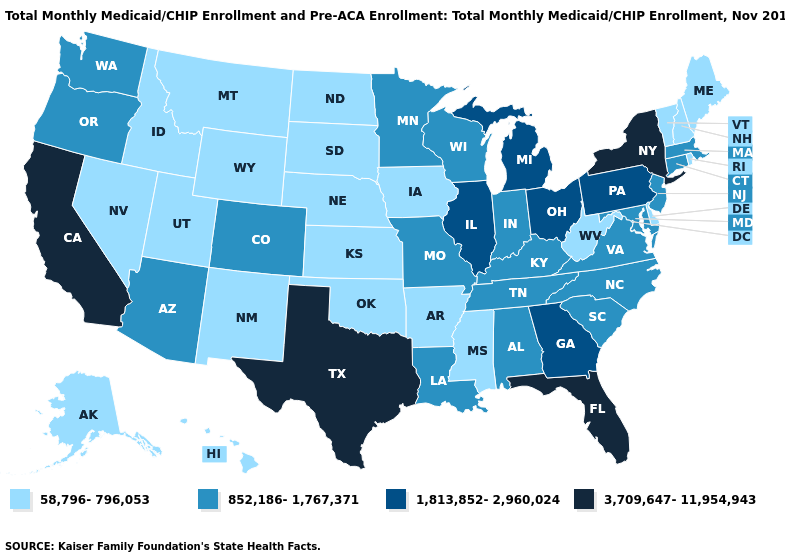How many symbols are there in the legend?
Concise answer only. 4. Is the legend a continuous bar?
Short answer required. No. What is the value of Connecticut?
Answer briefly. 852,186-1,767,371. Does Oregon have a higher value than New Hampshire?
Keep it brief. Yes. What is the value of Indiana?
Short answer required. 852,186-1,767,371. Name the states that have a value in the range 58,796-796,053?
Be succinct. Alaska, Arkansas, Delaware, Hawaii, Idaho, Iowa, Kansas, Maine, Mississippi, Montana, Nebraska, Nevada, New Hampshire, New Mexico, North Dakota, Oklahoma, Rhode Island, South Dakota, Utah, Vermont, West Virginia, Wyoming. What is the lowest value in the USA?
Answer briefly. 58,796-796,053. Among the states that border Missouri , does Nebraska have the lowest value?
Write a very short answer. Yes. What is the value of North Dakota?
Write a very short answer. 58,796-796,053. What is the value of Georgia?
Keep it brief. 1,813,852-2,960,024. What is the value of South Carolina?
Keep it brief. 852,186-1,767,371. What is the value of Georgia?
Write a very short answer. 1,813,852-2,960,024. Does the map have missing data?
Keep it brief. No. Name the states that have a value in the range 58,796-796,053?
Keep it brief. Alaska, Arkansas, Delaware, Hawaii, Idaho, Iowa, Kansas, Maine, Mississippi, Montana, Nebraska, Nevada, New Hampshire, New Mexico, North Dakota, Oklahoma, Rhode Island, South Dakota, Utah, Vermont, West Virginia, Wyoming. What is the highest value in states that border Maryland?
Keep it brief. 1,813,852-2,960,024. 